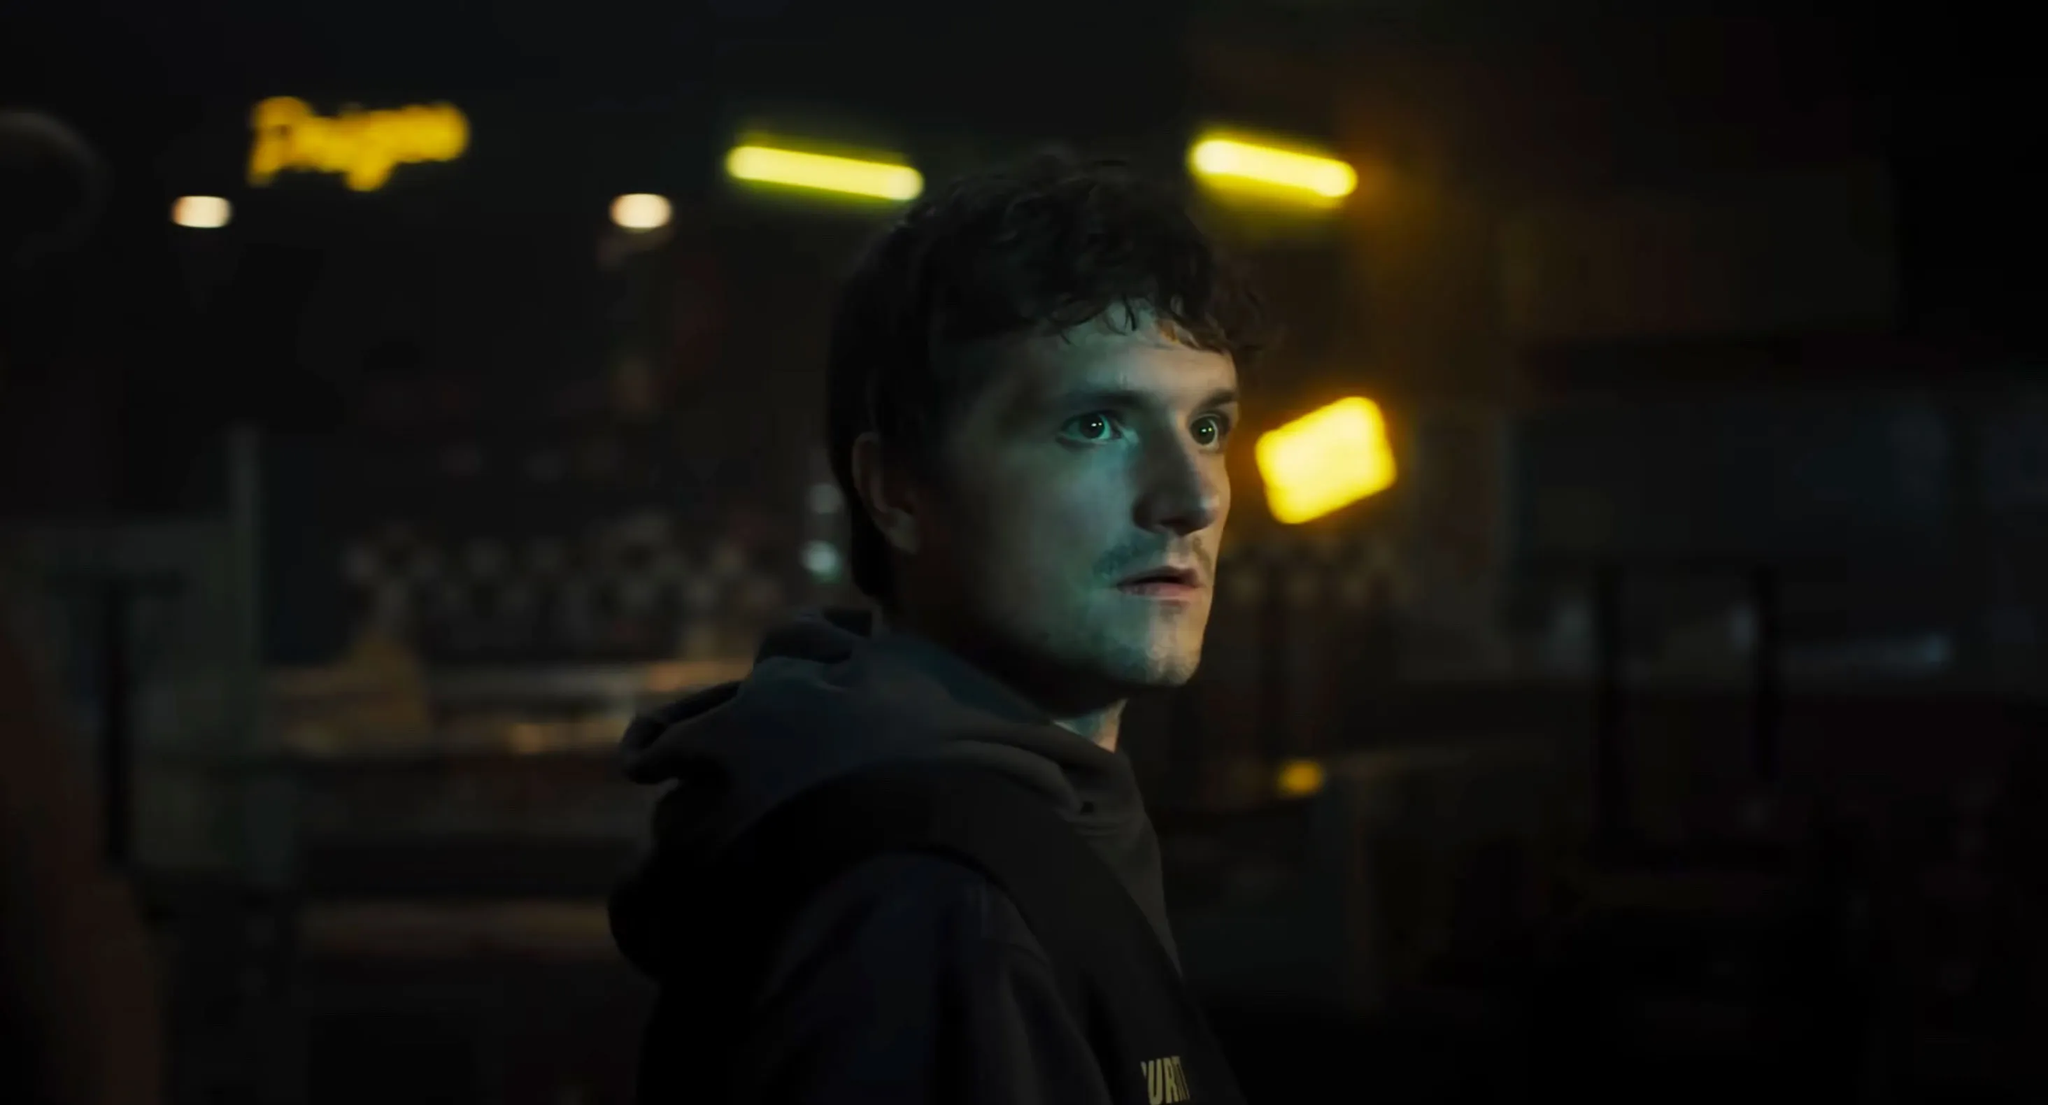What details make this image embody a sense of mystery and intrigue? Several elements in this image contribute to its sense of mystery and intrigue. The dim lighting and soft yellow lights create a moody and almost surreal atmosphere. The blurred neon sign in the background suggests an urban setting with a hint of chaos or disarray. The checkerboard pattern on the wall adds a retro, almost secretive vibe. The man's intense gaze and serious expression indicate that something significant is on his mind, leaving the viewer curious about his thoughts and the context of the scene. Create a possible dialogue that this character could be having in this setting. Man: *(whispers to himself)* "This is it. We don’t have much time left. The signals… they’re getting stronger." 
*(pauses, glancing over at the dim yellow lights)*
"I need to stay focused. Everything depends on this next move. The team is counting on me."
*(hears a faint noise, turns sharply)*
"Who's there? Show yourself. We need to talk."  Based on your last response, what's the significance of the signals the man mentions? The signals the man mentions could be secret communications or coded messages from other members of his resistance group. These signals might contain crucial information about the enemy's plans or the locations of hidden allies. The urgency in his voice indicates that deciphering them quickly is vital for their next mission. They could be the last pieces of a puzzle that, once solved, could turn the tide in their favor against the oppressive regime. 